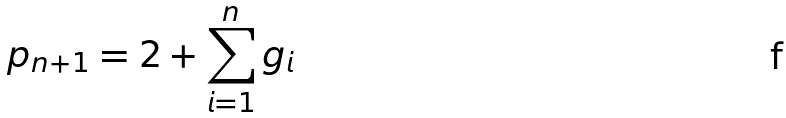<formula> <loc_0><loc_0><loc_500><loc_500>p _ { n + 1 } = 2 + \sum _ { i = 1 } ^ { n } g _ { i }</formula> 